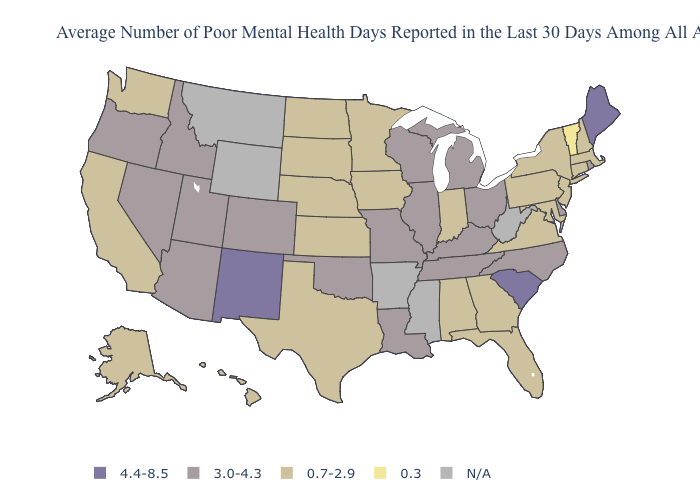Name the states that have a value in the range N/A?
Give a very brief answer. Arkansas, Mississippi, Montana, West Virginia, Wyoming. What is the value of Georgia?
Keep it brief. 0.7-2.9. Name the states that have a value in the range 0.7-2.9?
Keep it brief. Alabama, Alaska, California, Connecticut, Florida, Georgia, Hawaii, Indiana, Iowa, Kansas, Maryland, Massachusetts, Minnesota, Nebraska, New Hampshire, New Jersey, New York, North Dakota, Pennsylvania, South Dakota, Texas, Virginia, Washington. What is the lowest value in states that border West Virginia?
Be succinct. 0.7-2.9. Among the states that border Alabama , does Georgia have the lowest value?
Quick response, please. Yes. Does Minnesota have the lowest value in the MidWest?
Write a very short answer. Yes. What is the value of Montana?
Write a very short answer. N/A. What is the highest value in states that border Louisiana?
Write a very short answer. 0.7-2.9. Does North Dakota have the highest value in the USA?
Quick response, please. No. What is the lowest value in the USA?
Concise answer only. 0.3. What is the value of Missouri?
Write a very short answer. 3.0-4.3. Which states have the lowest value in the USA?
Concise answer only. Vermont. Among the states that border Arkansas , which have the highest value?
Be succinct. Louisiana, Missouri, Oklahoma, Tennessee. 